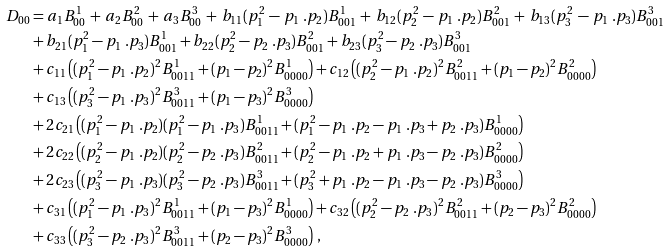Convert formula to latex. <formula><loc_0><loc_0><loc_500><loc_500>D _ { 0 0 } & = a _ { 1 } B _ { 0 0 } ^ { 1 } \, + \, a _ { 2 } B _ { 0 0 } ^ { 2 } \, + \, a _ { 3 } B _ { 0 0 } ^ { 3 } \, + \, b _ { 1 1 } ( p _ { 1 } ^ { 2 } \, - \, p _ { 1 } \ . p _ { 2 } ) B _ { 0 0 1 } ^ { 1 } \, + \, b _ { 1 2 } ( p _ { 2 } ^ { 2 } \, - \, p _ { 1 } \ . p _ { 2 } ) B _ { 0 0 1 } ^ { 2 } \, + \, b _ { 1 3 } ( p _ { 3 } ^ { 2 } \, - \, p _ { 1 } \ . p _ { 3 } ) B _ { 0 0 1 } ^ { 3 } \\ & + b _ { 2 1 } ( p _ { 1 } ^ { 2 } - p _ { 1 } \ . p _ { 3 } ) B _ { 0 0 1 } ^ { 1 } + b _ { 2 2 } ( p _ { 2 } ^ { 2 } - p _ { 2 } \ . p _ { 3 } ) B _ { 0 0 1 } ^ { 2 } + b _ { 2 3 } ( p _ { 3 } ^ { 2 } - p _ { 2 } \ . p _ { 3 } ) B _ { 0 0 1 } ^ { 3 } \\ & + c _ { 1 1 } \left ( ( p _ { 1 } ^ { 2 } - p _ { 1 } \ . p _ { 2 } ) ^ { 2 } B _ { 0 0 1 1 } ^ { 1 } + ( p _ { 1 } - p _ { 2 } ) ^ { 2 } B _ { 0 0 0 0 } ^ { 1 } \right ) + c _ { 1 2 } \left ( ( p _ { 2 } ^ { 2 } - p _ { 1 } \ . p _ { 2 } ) ^ { 2 } B _ { 0 0 1 1 } ^ { 2 } + ( p _ { 1 } - p _ { 2 } ) ^ { 2 } B _ { 0 0 0 0 } ^ { 2 } \right ) \\ & + c _ { 1 3 } \left ( ( p _ { 3 } ^ { 2 } - p _ { 1 } \ . p _ { 3 } ) ^ { 2 } B _ { 0 0 1 1 } ^ { 3 } + ( p _ { 1 } - p _ { 3 } ) ^ { 2 } B _ { 0 0 0 0 } ^ { 3 } \right ) \\ & + 2 c _ { 2 1 } \left ( ( p _ { 1 } ^ { 2 } - p _ { 1 } \ . p _ { 2 } ) ( p _ { 1 } ^ { 2 } - p _ { 1 } \ . p _ { 3 } ) B _ { 0 0 1 1 } ^ { 1 } + ( p _ { 1 } ^ { 2 } - p _ { 1 } \ . p _ { 2 } - p _ { 1 } \ . p _ { 3 } + p _ { 2 } \ . p _ { 3 } ) B _ { 0 0 0 0 } ^ { 1 } \right ) \\ & + 2 c _ { 2 2 } \left ( ( p _ { 2 } ^ { 2 } - p _ { 1 } \ . p _ { 2 } ) ( p _ { 2 } ^ { 2 } - p _ { 2 } \ . p _ { 3 } ) B _ { 0 0 1 1 } ^ { 2 } + ( p _ { 2 } ^ { 2 } - p _ { 1 } \ . p _ { 2 } + p _ { 1 } \ . p _ { 3 } - p _ { 2 } \ . p _ { 3 } ) B _ { 0 0 0 0 } ^ { 2 } \right ) \\ & + 2 c _ { 2 3 } \left ( ( p _ { 3 } ^ { 2 } - p _ { 1 } \ . p _ { 3 } ) ( p _ { 3 } ^ { 2 } - p _ { 2 } \ . p _ { 3 } ) B _ { 0 0 1 1 } ^ { 3 } + ( p _ { 3 } ^ { 2 } + p _ { 1 } \ . p _ { 2 } - p _ { 1 } \ . p _ { 3 } - p _ { 2 } \ . p _ { 3 } ) B _ { 0 0 0 0 } ^ { 3 } \right ) \\ & + c _ { 3 1 } \left ( ( p _ { 1 } ^ { 2 } - p _ { 1 } \ . p _ { 3 } ) ^ { 2 } B _ { 0 0 1 1 } ^ { 1 } + ( p _ { 1 } - p _ { 3 } ) ^ { 2 } B _ { 0 0 0 0 } ^ { 1 } \right ) + c _ { 3 2 } \left ( ( p _ { 2 } ^ { 2 } - p _ { 2 } \ . p _ { 3 } ) ^ { 2 } B _ { 0 0 1 1 } ^ { 2 } + ( p _ { 2 } - p _ { 3 } ) ^ { 2 } B _ { 0 0 0 0 } ^ { 2 } \right ) \\ & + c _ { 3 3 } \left ( ( p _ { 3 } ^ { 2 } - p _ { 2 } \ . p _ { 3 } ) ^ { 2 } B _ { 0 0 1 1 } ^ { 3 } + ( p _ { 2 } - p _ { 3 } ) ^ { 2 } B _ { 0 0 0 0 } ^ { 3 } \right ) \, ,</formula> 